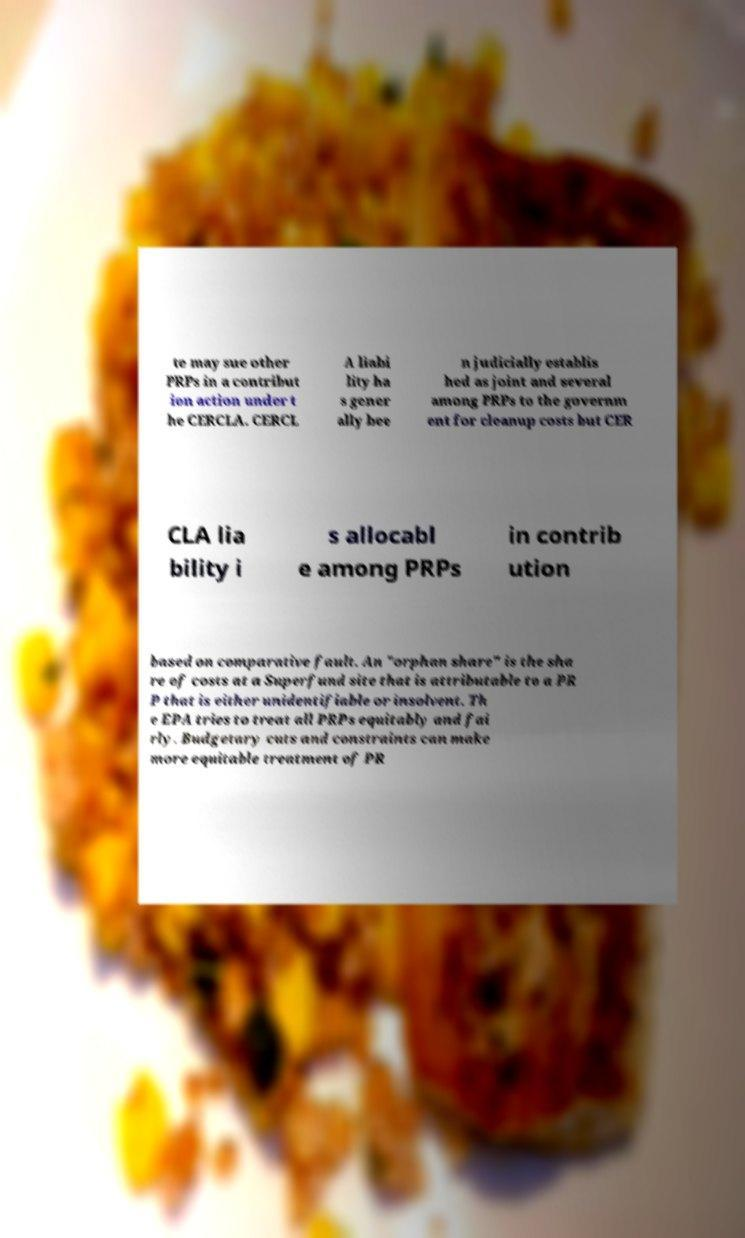Could you extract and type out the text from this image? te may sue other PRPs in a contribut ion action under t he CERCLA. CERCL A liabi lity ha s gener ally bee n judicially establis hed as joint and several among PRPs to the governm ent for cleanup costs but CER CLA lia bility i s allocabl e among PRPs in contrib ution based on comparative fault. An "orphan share" is the sha re of costs at a Superfund site that is attributable to a PR P that is either unidentifiable or insolvent. Th e EPA tries to treat all PRPs equitably and fai rly. Budgetary cuts and constraints can make more equitable treatment of PR 